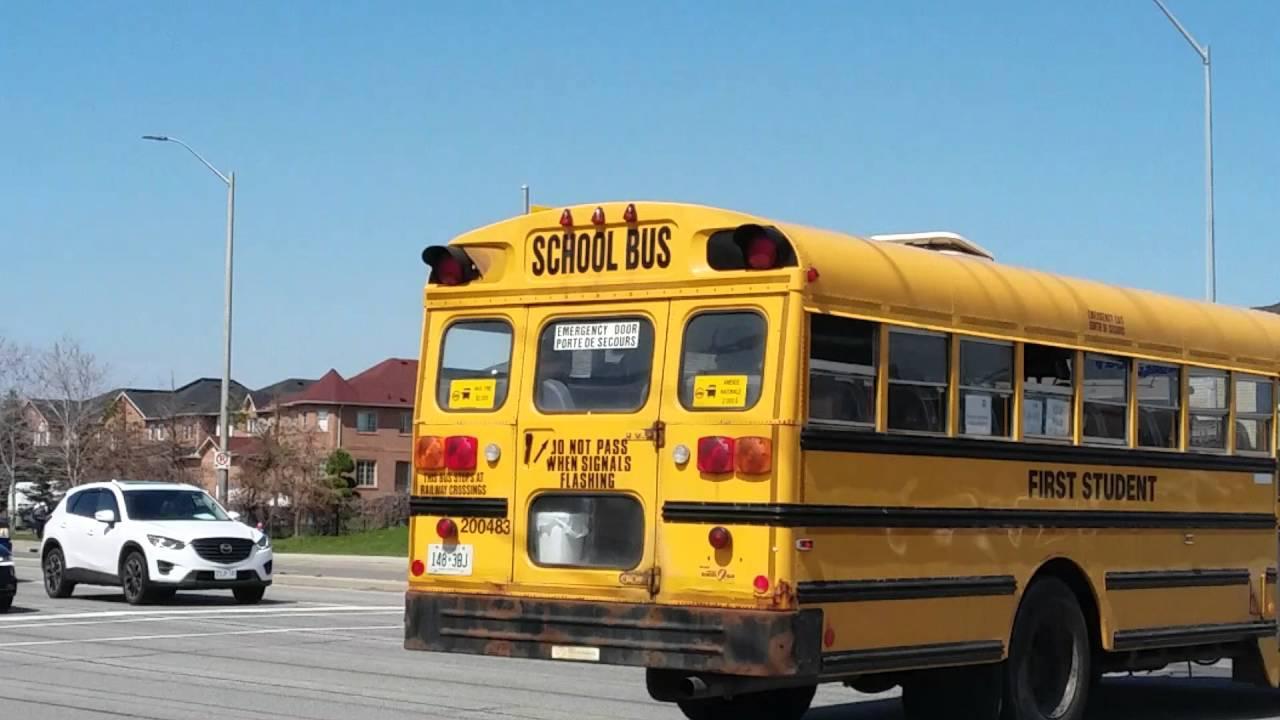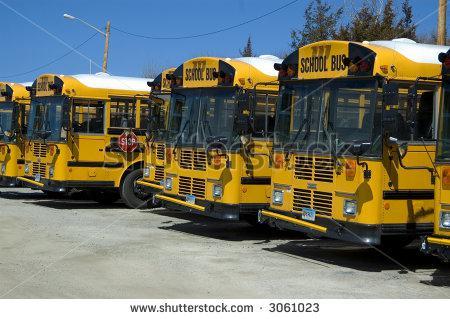The first image is the image on the left, the second image is the image on the right. Assess this claim about the two images: "The buses on the right are parked in a row and facing toward the camera.". Correct or not? Answer yes or no. Yes. 